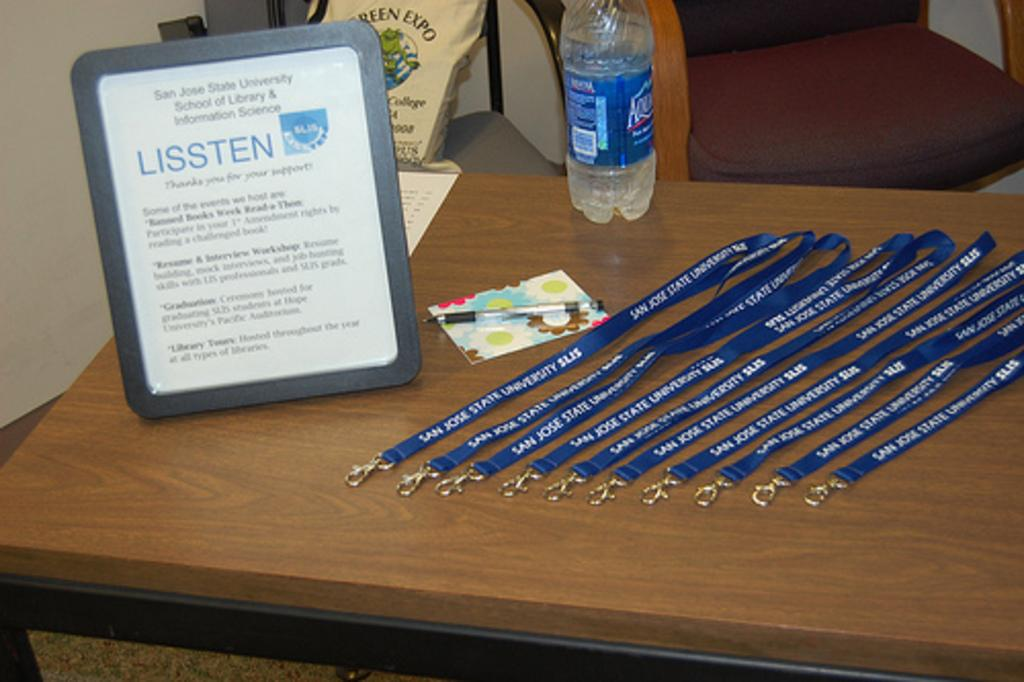What piece of furniture is present in the image? There is a table in the image. What items can be seen on the table? There are id card bands, a photo frame, a card, a pen, and a water bottle on the table. Is there any other object in the image besides the table? Yes, there is a bag on a chair in the image. How does the harmony of the objects on the table contribute to the overall aesthetic of the image? The provided facts do not mention any aspect of harmony or aesthetics, so it is not possible to answer this question based on the information given. 